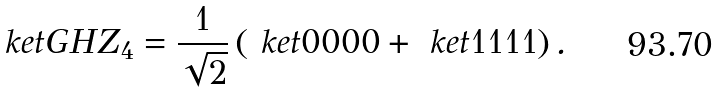<formula> <loc_0><loc_0><loc_500><loc_500>\ k e t { \text {GHZ} _ { 4 } } = \frac { 1 } { \sqrt { 2 } } \left ( \ k e t { 0 0 0 0 } + \ k e t { 1 1 1 1 } \right ) .</formula> 